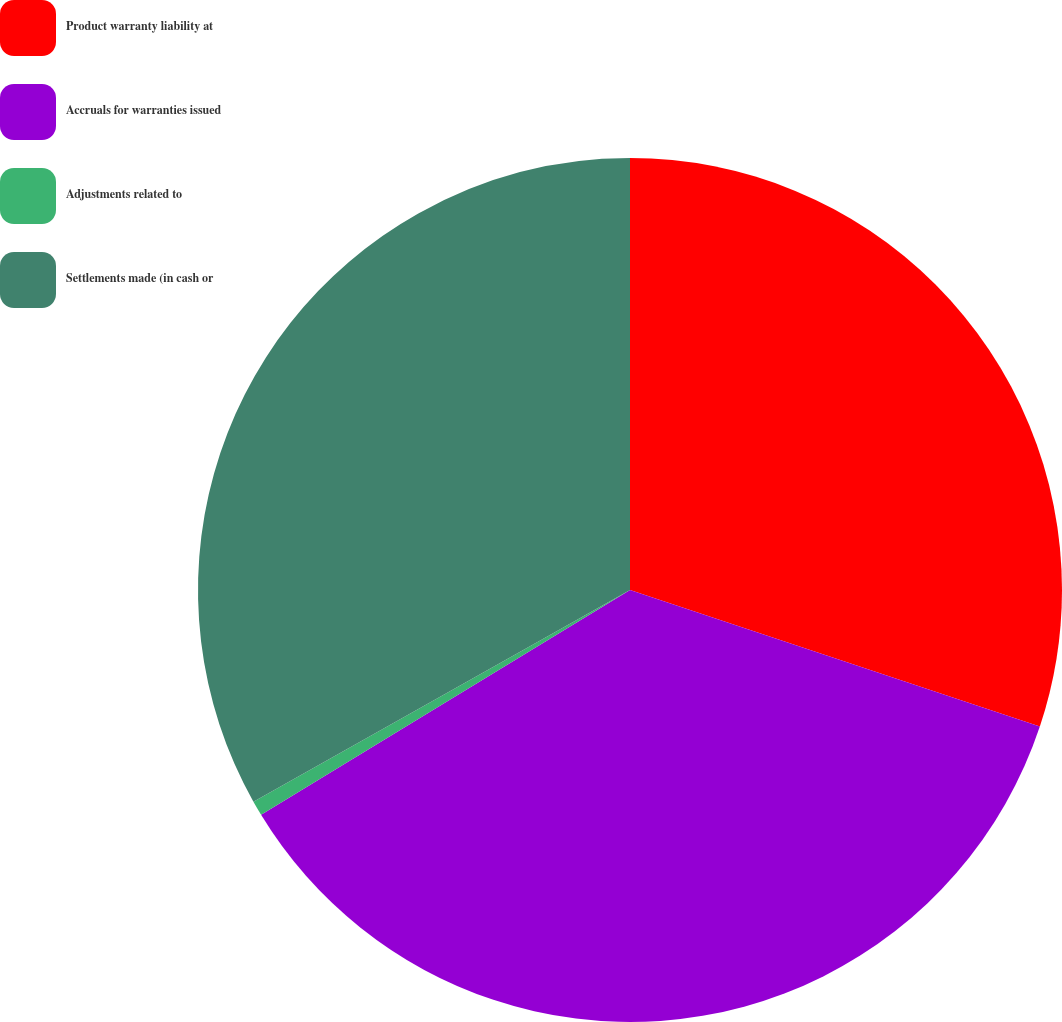Convert chart. <chart><loc_0><loc_0><loc_500><loc_500><pie_chart><fcel>Product warranty liability at<fcel>Accruals for warranties issued<fcel>Adjustments related to<fcel>Settlements made (in cash or<nl><fcel>30.12%<fcel>36.17%<fcel>0.56%<fcel>33.15%<nl></chart> 